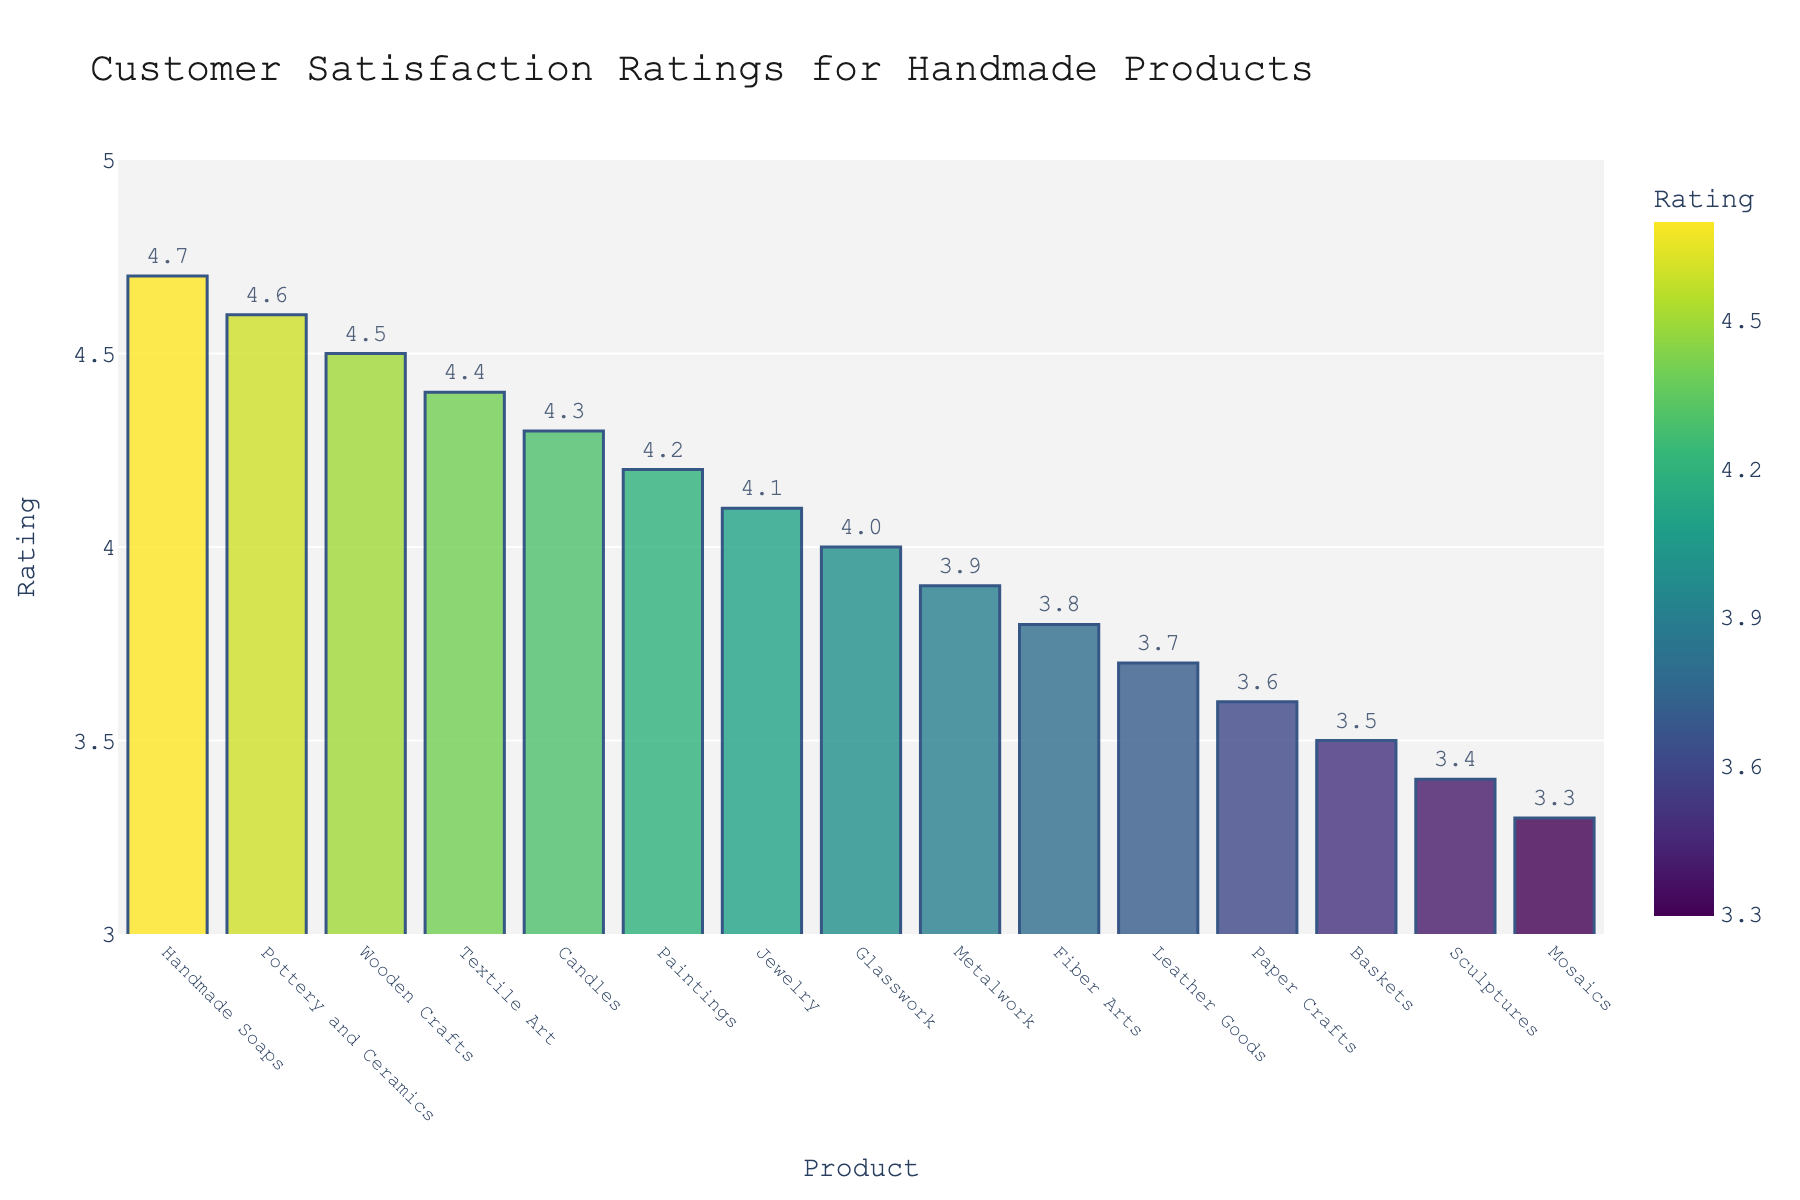Which product has the highest average satisfaction rating? The bar chart shows various handmade products with their average satisfaction ratings. Locate the tallest bar, which represents the highest rating.
Answer: Handmade Soaps Which two products have the closest average satisfaction ratings? Identify the bars with the closest heights in the chart, then compare their ratings.
Answer: Metalwork and Fiber Arts What is the average satisfaction rating for products rated 4.3 or higher? Identify products with ratings 4.3 or above: Handmade Soaps (4.7), Pottery and Ceramics (4.6), Wooden Crafts (4.5), Textile Art (4.4), and Candles (4.3). Calculate the average: (4.7 + 4.6 + 4.5 + 4.4 + 4.3) / 5 = 4.5
Answer: 4.5 Which product has a rating exactly at 4.0? Look for the bar labeled with the average satisfaction rating of 4.0 in the chart.
Answer: Glasswork Which product types have average satisfaction ratings less than 4.0? Identify all the bars with heights indicating ratings below 4.0 in the chart.
Answer: Metalwork, Fiber Arts, Leather Goods, Paper Crafts, Baskets, Sculptures, Mosaics What is the difference in average satisfaction rating between Handmade Soaps and Mosaics? Find the ratings of both products in the chart: Handmade Soaps (4.7) and Mosaics (3.3). Calculate the difference: 4.7 - 3.3 = 1.4
Answer: 1.4 How many products have an average satisfaction rating of 4.5 or higher? Count the number of bars that have a rating greater than or equal to 4.5. These are Handmade Soaps (4.7), Pottery and Ceramics (4.6), and Wooden Crafts (4.5).
Answer: 3 What is the rating range covered by Textile Art, Glasswork, and Leather Goods? Locate the ratings: Textile Art (4.4), Glasswork (4.0), and Leather Goods (3.7). Determine the range by subtracting the lowest rating from the highest: 4.4 - 3.7 = 0.7
Answer: 0.7 Which product type has the second highest average satisfaction rating? Find the second tallest bar in the chart, which follows the tallest bar.
Answer: Pottery and Ceramics Is the average satisfaction rating of Paintings higher than that of Candles? Compare the heights of the bars representing Paintings and Candles. Paintings (4.2) and Candles (4.3).
Answer: No 